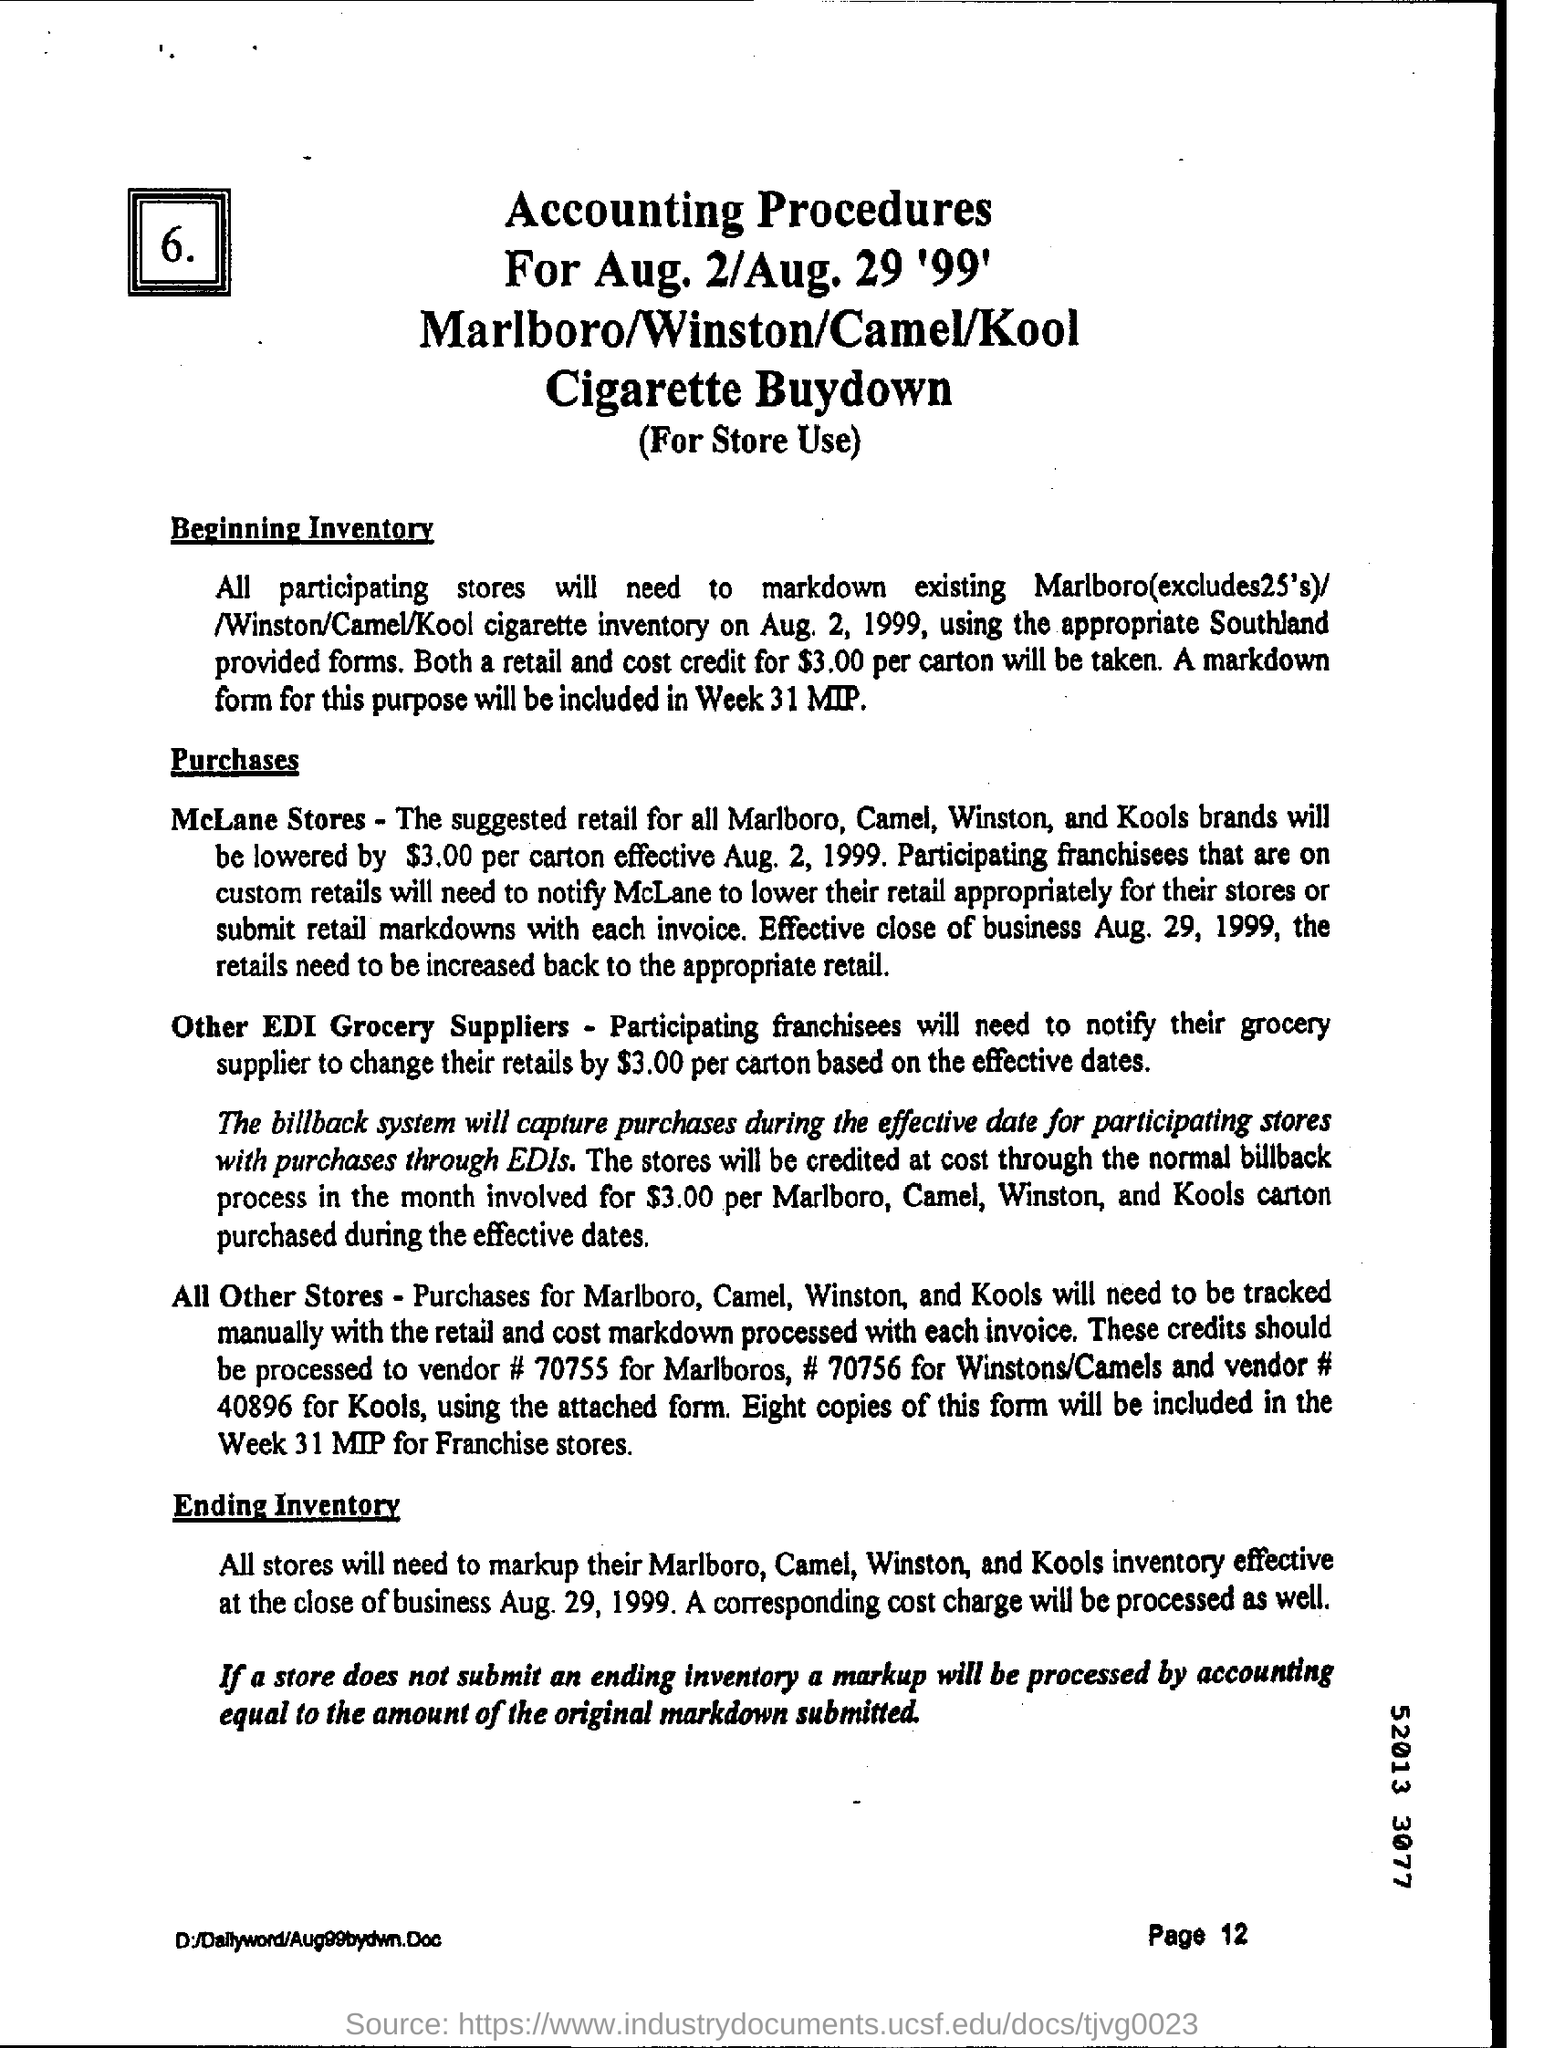What is the page number written on the bottom?
Your response must be concise. Page 12. 